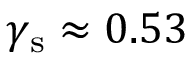<formula> <loc_0><loc_0><loc_500><loc_500>\gamma _ { s } \approx 0 . 5 3</formula> 